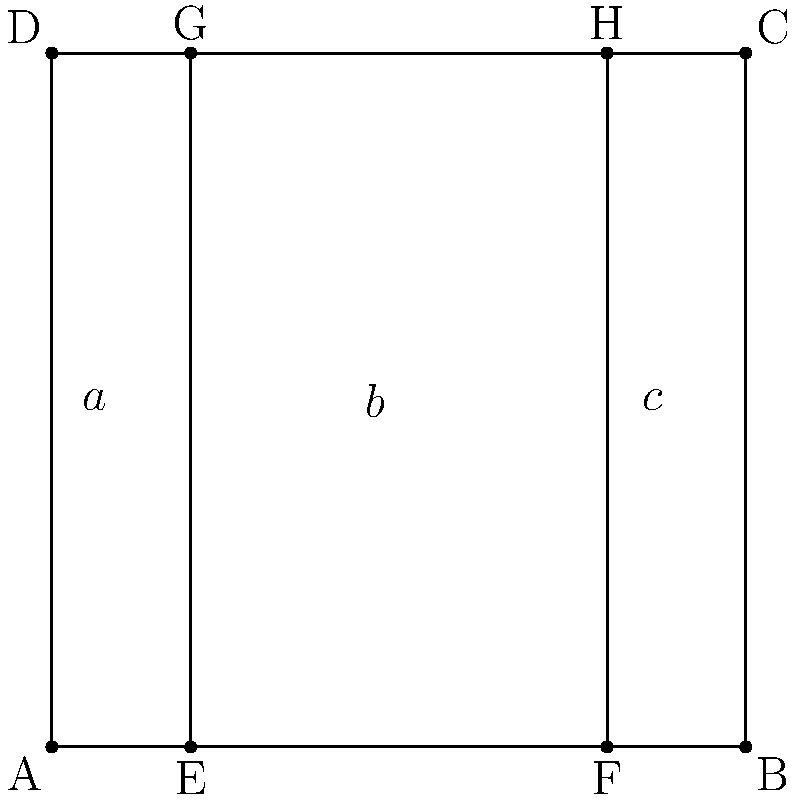The facade of Hawa Mahal in Jaipur is known for its unique architecture. A simplified representation of its front view is shown above, where the width is divided into three sections: $a$, $b$, and $c$. If the total width of the facade is 50 meters and the ratio of $a:b:c$ follows the golden ratio, calculate the width of the middle section $b$ in meters. Round your answer to two decimal places.

Note: The golden ratio is approximately 1.618 and is denoted by $\phi$. Let's approach this step-by-step:

1) The golden ratio states that $\frac{a+b}{b} = \frac{b}{a} = \phi \approx 1.618$

2) Given the facade is divided into three sections following the golden ratio, we can write:
   $\frac{a+b}{b} = \frac{b}{a} = \frac{b+c}{c} = \phi$

3) This means that $a:b:c = 1 : \phi : 1$

4) Let's denote the total width as $w$. We know $w = 50$ meters.

5) We can write: $w = a + b + c = 1 + \phi + 1 = \phi + 2$

6) Now, we can find $b$:
   $\frac{b}{w} = \frac{\phi}{\phi + 2}$

7) Substituting the known values:
   $b = 50 \cdot \frac{\phi}{\phi + 2}$

8) Using $\phi \approx 1.618$:
   $b = 50 \cdot \frac{1.618}{1.618 + 2} = 50 \cdot \frac{1.618}{3.618} \approx 22.36$ meters

9) Rounding to two decimal places: $b \approx 22.36$ meters
Answer: 22.36 meters 